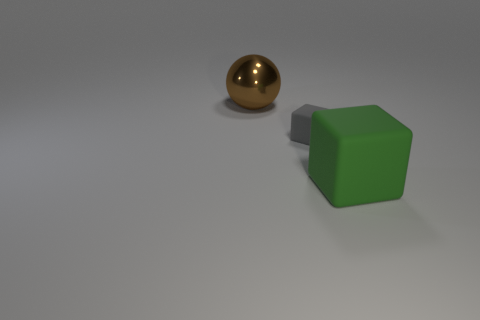Add 1 gray things. How many objects exist? 4 Subtract all spheres. How many objects are left? 2 Add 3 large metallic objects. How many large metallic objects exist? 4 Subtract 1 green blocks. How many objects are left? 2 Subtract all small gray matte spheres. Subtract all large green things. How many objects are left? 2 Add 3 large matte objects. How many large matte objects are left? 4 